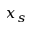Convert formula to latex. <formula><loc_0><loc_0><loc_500><loc_500>x _ { s }</formula> 